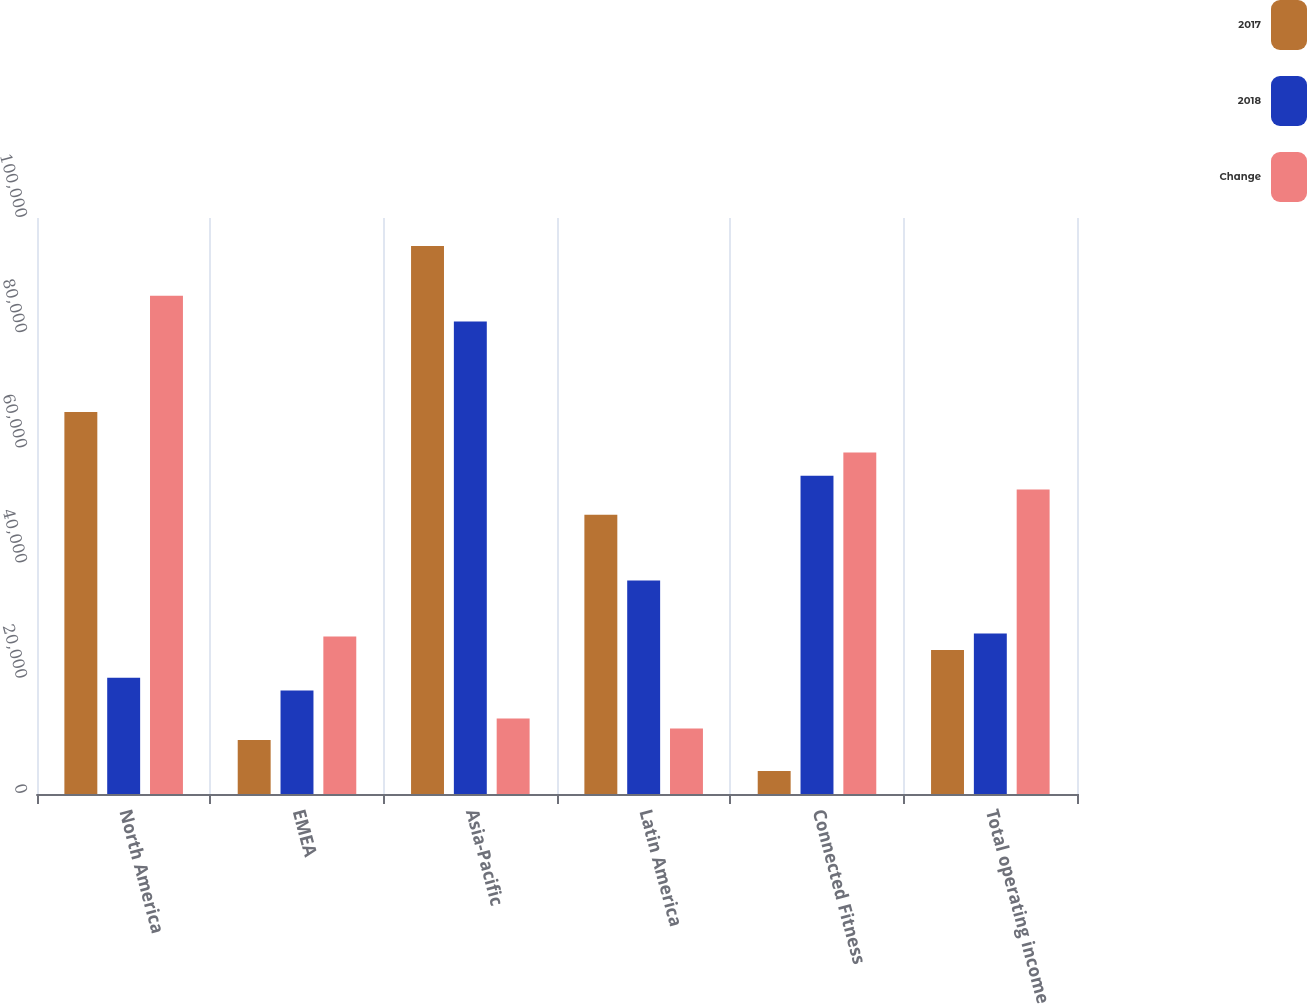Convert chart to OTSL. <chart><loc_0><loc_0><loc_500><loc_500><stacked_bar_chart><ecel><fcel>North America<fcel>EMEA<fcel>Asia-Pacific<fcel>Latin America<fcel>Connected Fitness<fcel>Total operating income<nl><fcel>2017<fcel>66305<fcel>9379<fcel>95128<fcel>48470<fcel>4009<fcel>25017<nl><fcel>2018<fcel>20179<fcel>17976<fcel>82039<fcel>37085<fcel>55266<fcel>27843<nl><fcel>Change<fcel>86484<fcel>27355<fcel>13089<fcel>11385<fcel>59275<fcel>52860<nl></chart> 